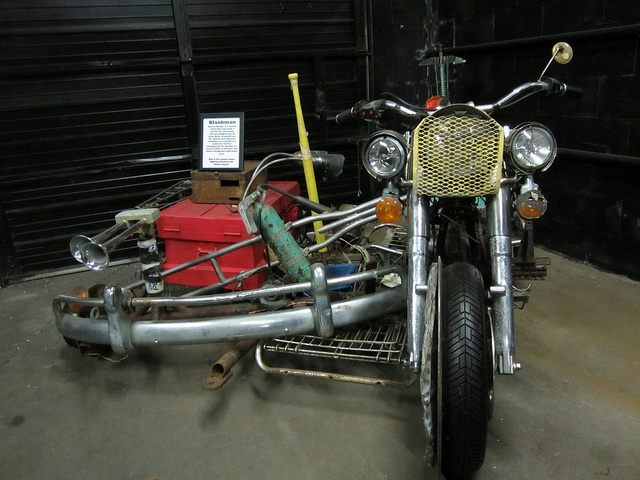Describe the objects in this image and their specific colors. I can see a motorcycle in black, gray, darkgray, and tan tones in this image. 